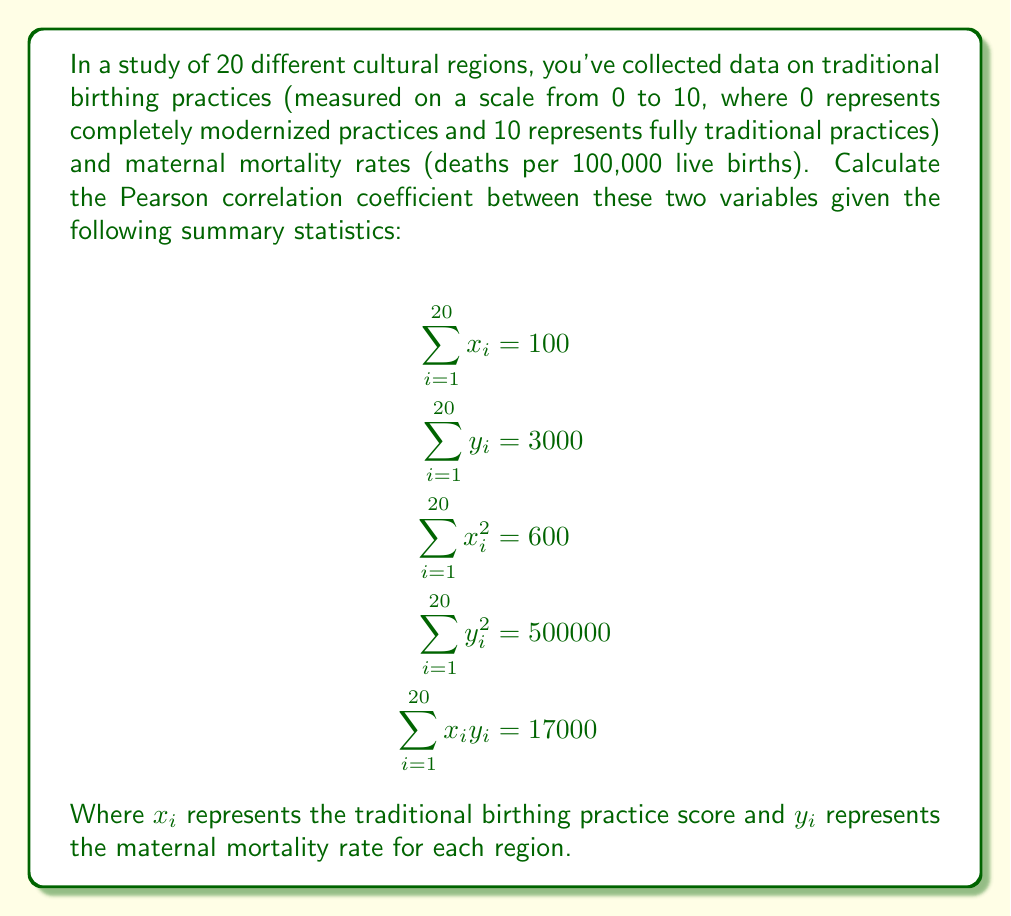Can you solve this math problem? To calculate the Pearson correlation coefficient, we'll use the formula:

$$r = \frac{n\sum x_iy_i - (\sum x_i)(\sum y_i)}{\sqrt{[n\sum x_i^2 - (\sum x_i)^2][n\sum y_i^2 - (\sum y_i)^2]}}$$

Where $n$ is the number of data points (20 in this case).

Step 1: Calculate the numerator
$$n\sum x_iy_i - (\sum x_i)(\sum y_i) = 20(17000) - (100)(3000) = 340000 - 300000 = 40000$$

Step 2: Calculate the first part of the denominator
$$n\sum x_i^2 - (\sum x_i)^2 = 20(600) - (100)^2 = 12000 - 10000 = 2000$$

Step 3: Calculate the second part of the denominator
$$n\sum y_i^2 - (\sum y_i)^2 = 20(500000) - (3000)^2 = 10000000 - 9000000 = 1000000$$

Step 4: Multiply the two parts of the denominator and take the square root
$$\sqrt{(2000)(1000000)} = \sqrt{2000000000} = 44721.36$$

Step 5: Divide the numerator by the denominator
$$r = \frac{40000}{44721.36} = 0.8944$$
Answer: $r \approx 0.8944$ 